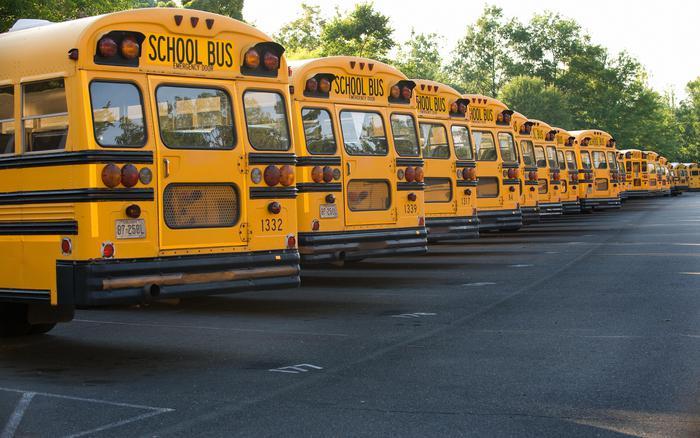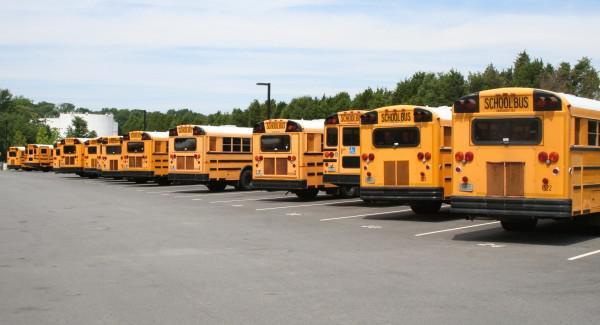The first image is the image on the left, the second image is the image on the right. Analyze the images presented: Is the assertion "All the buses are stopped or parked within close proximity to trees." valid? Answer yes or no. Yes. The first image is the image on the left, the second image is the image on the right. Examine the images to the left and right. Is the description "There is a school bus that will need immediate repair." accurate? Answer yes or no. No. 